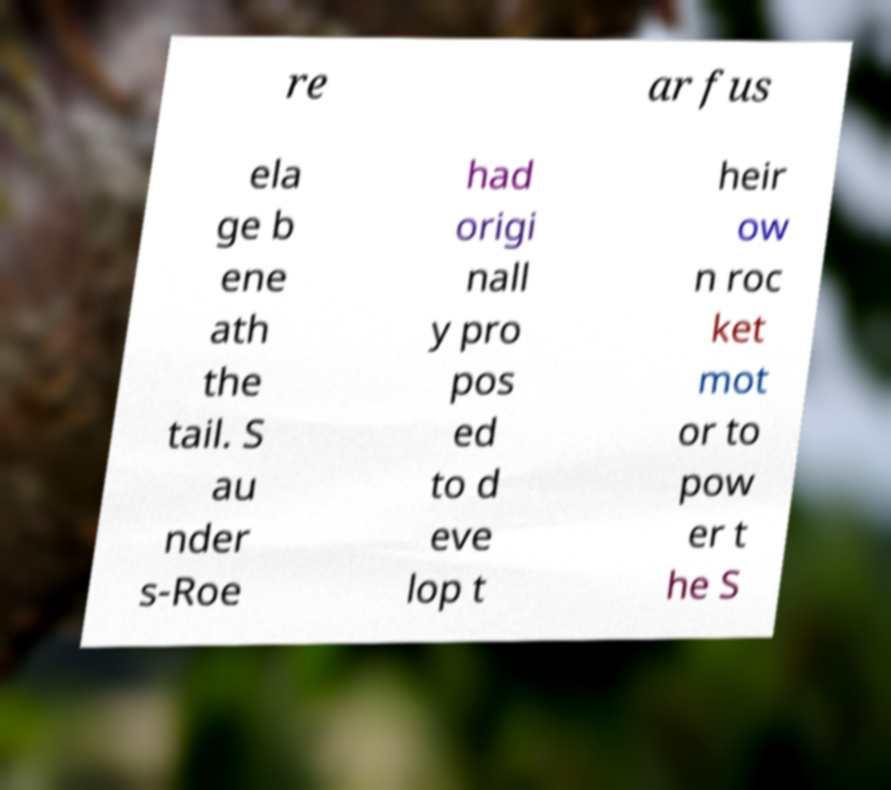For documentation purposes, I need the text within this image transcribed. Could you provide that? re ar fus ela ge b ene ath the tail. S au nder s-Roe had origi nall y pro pos ed to d eve lop t heir ow n roc ket mot or to pow er t he S 